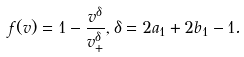Convert formula to latex. <formula><loc_0><loc_0><loc_500><loc_500>f ( v ) = 1 - \frac { v ^ { \delta } } { v ^ { \delta } _ { + } } , \delta = 2 a _ { 1 } + 2 b _ { 1 } - 1 .</formula> 